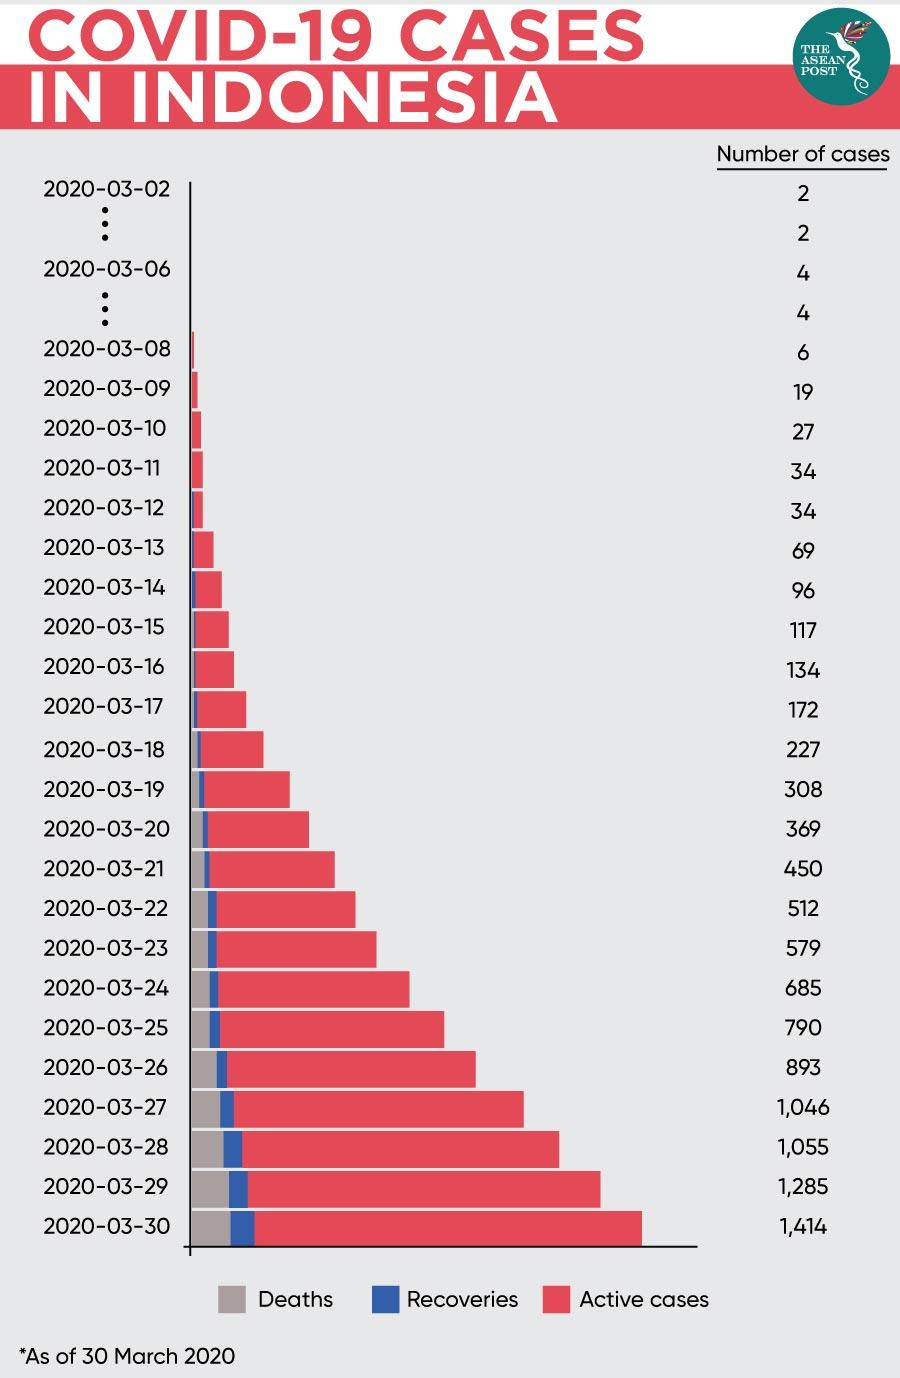Give some essential details in this illustration. As of March 30, 2022, a total of 1,414 cases of Covid-19 had been reported in Indonesia. As of March 28th, 2022, a total of 1,055 Covid-19 cases had been reported in Indonesia. 